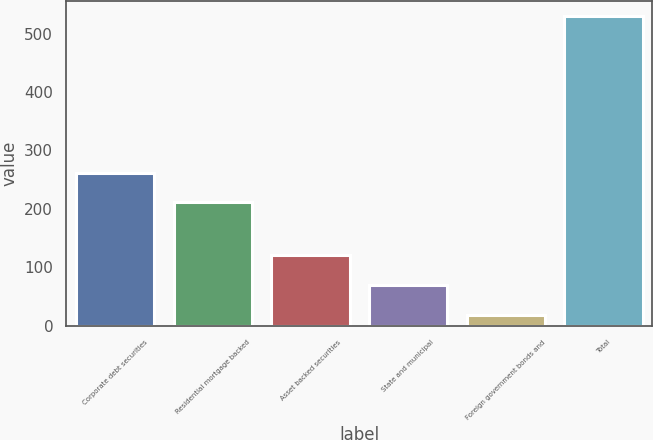Convert chart. <chart><loc_0><loc_0><loc_500><loc_500><bar_chart><fcel>Corporate debt securities<fcel>Residential mortgage backed<fcel>Asset backed securities<fcel>State and municipal<fcel>Foreign government bonds and<fcel>Total<nl><fcel>262.2<fcel>211<fcel>120.4<fcel>69.2<fcel>18<fcel>530<nl></chart> 